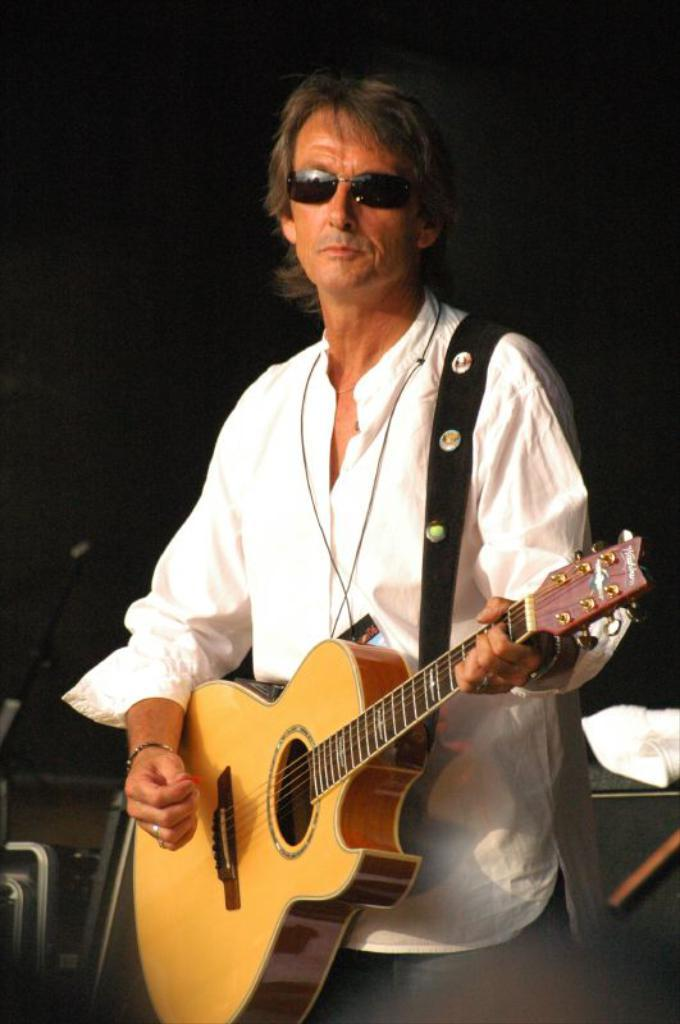Who is the main subject in the image? There is a man in the image. What is the man wearing on his upper body? The man is wearing a white shirt. What type of pants is the man wearing? The man is wearing jeans. What is the man wearing on his face? The man is wearing goggles. What is the man doing in the image? The man is playing a guitar. What is the color of the background in the image? The background of the image is dark. What type of jewel is the man wearing on his tongue in the image? There is no jewel visible on the man's tongue in the image. 